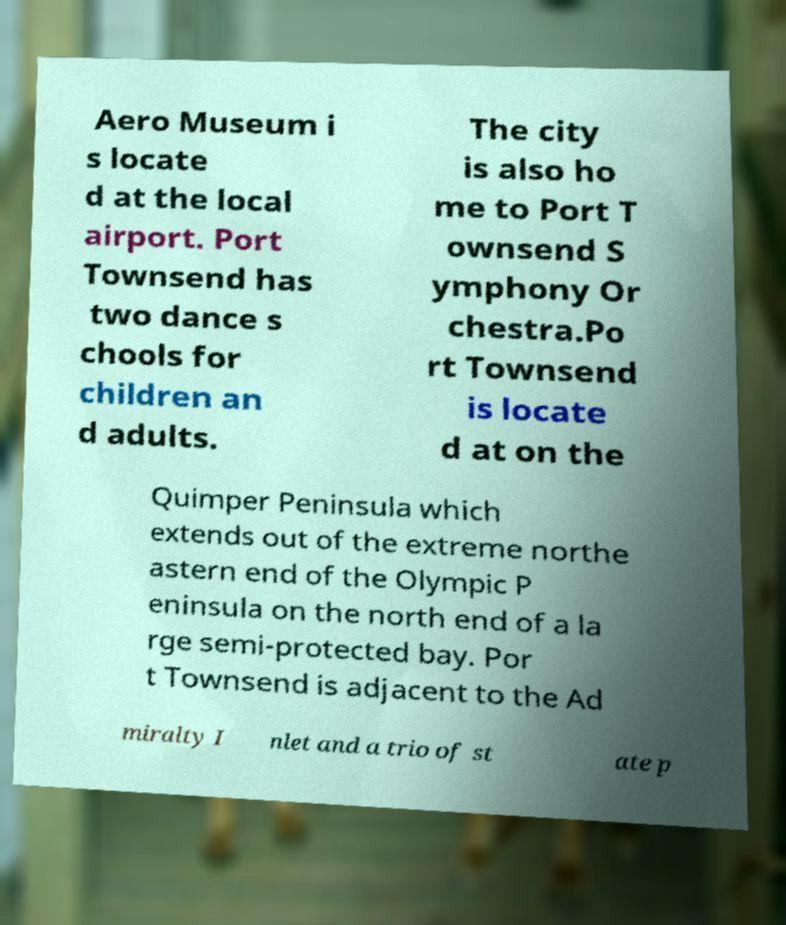For documentation purposes, I need the text within this image transcribed. Could you provide that? Aero Museum i s locate d at the local airport. Port Townsend has two dance s chools for children an d adults. The city is also ho me to Port T ownsend S ymphony Or chestra.Po rt Townsend is locate d at on the Quimper Peninsula which extends out of the extreme northe astern end of the Olympic P eninsula on the north end of a la rge semi-protected bay. Por t Townsend is adjacent to the Ad miralty I nlet and a trio of st ate p 